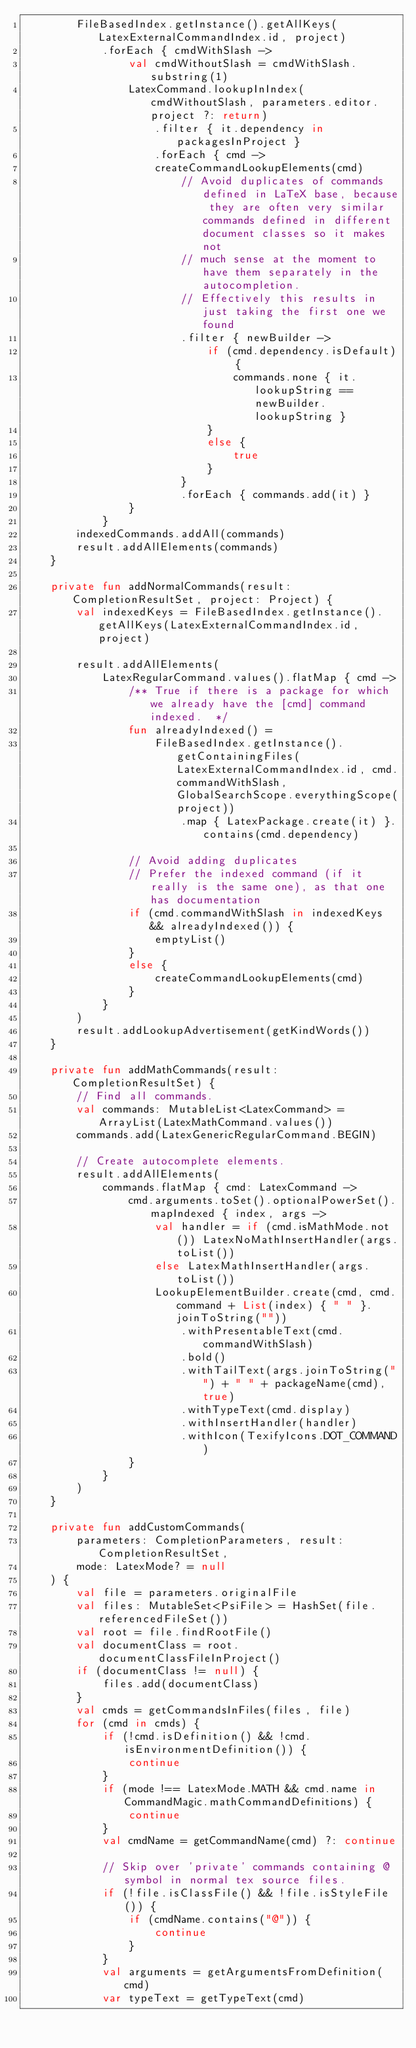<code> <loc_0><loc_0><loc_500><loc_500><_Kotlin_>        FileBasedIndex.getInstance().getAllKeys(LatexExternalCommandIndex.id, project)
            .forEach { cmdWithSlash ->
                val cmdWithoutSlash = cmdWithSlash.substring(1)
                LatexCommand.lookupInIndex(cmdWithoutSlash, parameters.editor.project ?: return)
                    .filter { it.dependency in packagesInProject }
                    .forEach { cmd ->
                    createCommandLookupElements(cmd)
                        // Avoid duplicates of commands defined in LaTeX base, because they are often very similar commands defined in different document classes so it makes not
                        // much sense at the moment to have them separately in the autocompletion.
                        // Effectively this results in just taking the first one we found
                        .filter { newBuilder ->
                            if (cmd.dependency.isDefault) {
                                commands.none { it.lookupString == newBuilder.lookupString }
                            }
                            else {
                                true
                            }
                        }
                        .forEach { commands.add(it) }
                }
            }
        indexedCommands.addAll(commands)
        result.addAllElements(commands)
    }

    private fun addNormalCommands(result: CompletionResultSet, project: Project) {
        val indexedKeys = FileBasedIndex.getInstance().getAllKeys(LatexExternalCommandIndex.id, project)

        result.addAllElements(
            LatexRegularCommand.values().flatMap { cmd ->
                /** True if there is a package for which we already have the [cmd] command indexed.  */
                fun alreadyIndexed() =
                    FileBasedIndex.getInstance().getContainingFiles(LatexExternalCommandIndex.id, cmd.commandWithSlash, GlobalSearchScope.everythingScope(project))
                        .map { LatexPackage.create(it) }.contains(cmd.dependency)

                // Avoid adding duplicates
                // Prefer the indexed command (if it really is the same one), as that one has documentation
                if (cmd.commandWithSlash in indexedKeys && alreadyIndexed()) {
                    emptyList()
                }
                else {
                    createCommandLookupElements(cmd)
                }
            }
        )
        result.addLookupAdvertisement(getKindWords())
    }

    private fun addMathCommands(result: CompletionResultSet) {
        // Find all commands.
        val commands: MutableList<LatexCommand> = ArrayList(LatexMathCommand.values())
        commands.add(LatexGenericRegularCommand.BEGIN)

        // Create autocomplete elements.
        result.addAllElements(
            commands.flatMap { cmd: LatexCommand ->
                cmd.arguments.toSet().optionalPowerSet().mapIndexed { index, args ->
                    val handler = if (cmd.isMathMode.not()) LatexNoMathInsertHandler(args.toList())
                    else LatexMathInsertHandler(args.toList())
                    LookupElementBuilder.create(cmd, cmd.command + List(index) { " " }.joinToString(""))
                        .withPresentableText(cmd.commandWithSlash)
                        .bold()
                        .withTailText(args.joinToString("") + " " + packageName(cmd), true)
                        .withTypeText(cmd.display)
                        .withInsertHandler(handler)
                        .withIcon(TexifyIcons.DOT_COMMAND)
                }
            }
        )
    }

    private fun addCustomCommands(
        parameters: CompletionParameters, result: CompletionResultSet,
        mode: LatexMode? = null
    ) {
        val file = parameters.originalFile
        val files: MutableSet<PsiFile> = HashSet(file.referencedFileSet())
        val root = file.findRootFile()
        val documentClass = root.documentClassFileInProject()
        if (documentClass != null) {
            files.add(documentClass)
        }
        val cmds = getCommandsInFiles(files, file)
        for (cmd in cmds) {
            if (!cmd.isDefinition() && !cmd.isEnvironmentDefinition()) {
                continue
            }
            if (mode !== LatexMode.MATH && cmd.name in CommandMagic.mathCommandDefinitions) {
                continue
            }
            val cmdName = getCommandName(cmd) ?: continue

            // Skip over 'private' commands containing @ symbol in normal tex source files.
            if (!file.isClassFile() && !file.isStyleFile()) {
                if (cmdName.contains("@")) {
                    continue
                }
            }
            val arguments = getArgumentsFromDefinition(cmd)
            var typeText = getTypeText(cmd)</code> 